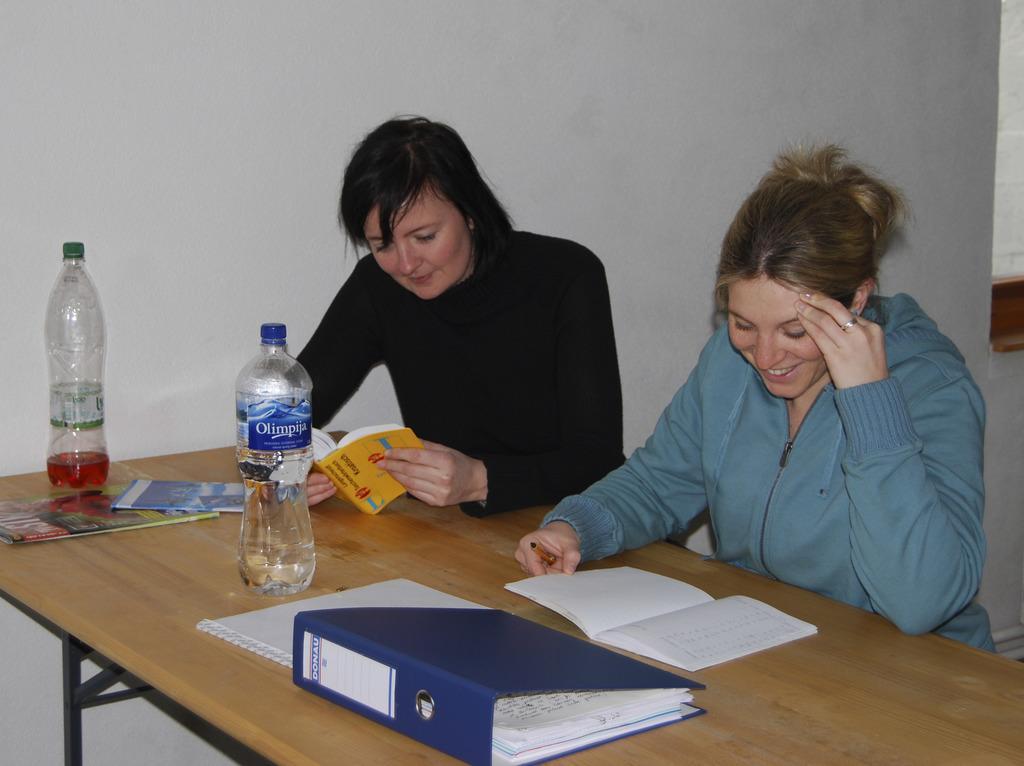In one or two sentences, can you explain what this image depicts? In this image I can see two women are sitting in front of a table. On this table I can see two bottles and a file. I can also see smile on their faces. 